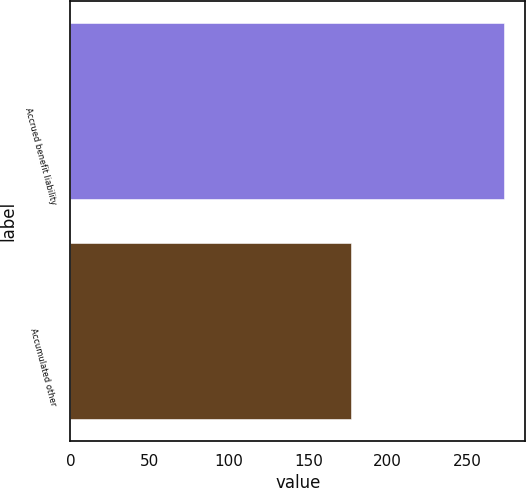<chart> <loc_0><loc_0><loc_500><loc_500><bar_chart><fcel>Accrued benefit liability<fcel>Accumulated other<nl><fcel>273<fcel>177<nl></chart> 